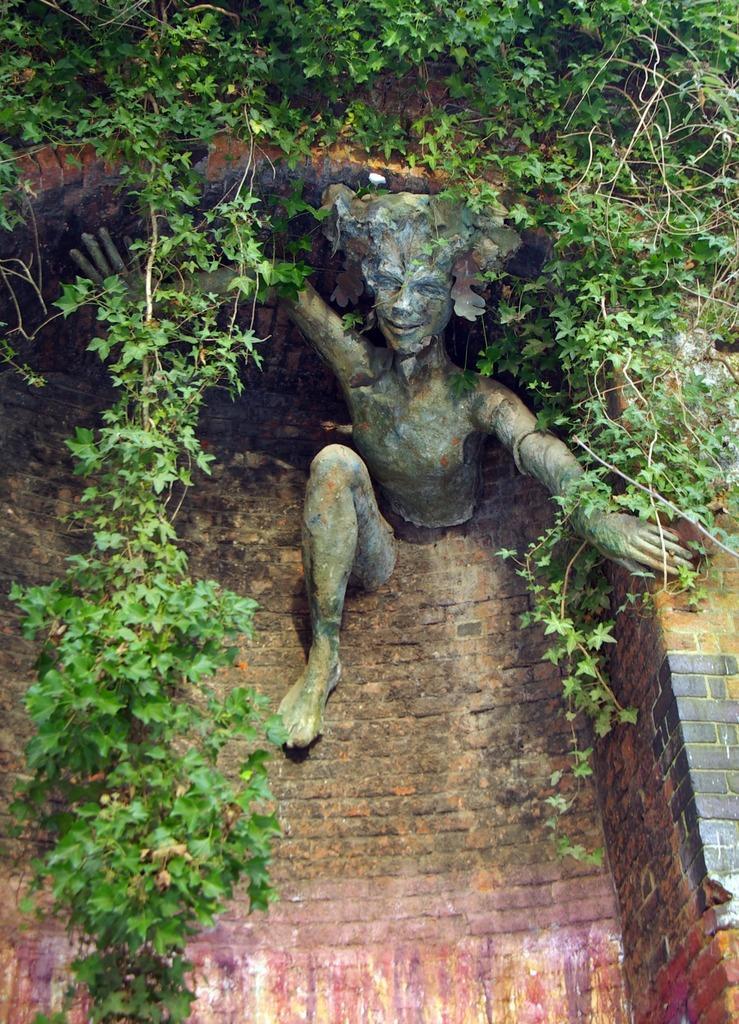Please provide a concise description of this image. In the image we can see a sculpture of a person. Here we can see the wall and the leaves. 